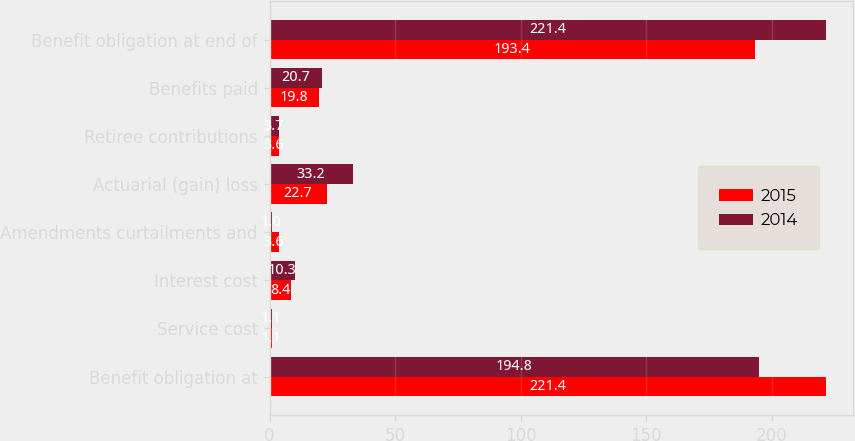Convert chart. <chart><loc_0><loc_0><loc_500><loc_500><stacked_bar_chart><ecel><fcel>Benefit obligation at<fcel>Service cost<fcel>Interest cost<fcel>Amendments curtailments and<fcel>Actuarial (gain) loss<fcel>Retiree contributions<fcel>Benefits paid<fcel>Benefit obligation at end of<nl><fcel>2015<fcel>221.4<fcel>1.1<fcel>8.4<fcel>3.6<fcel>22.7<fcel>3.6<fcel>19.8<fcel>193.4<nl><fcel>2014<fcel>194.8<fcel>1.1<fcel>10.3<fcel>1<fcel>33.2<fcel>3.7<fcel>20.7<fcel>221.4<nl></chart> 